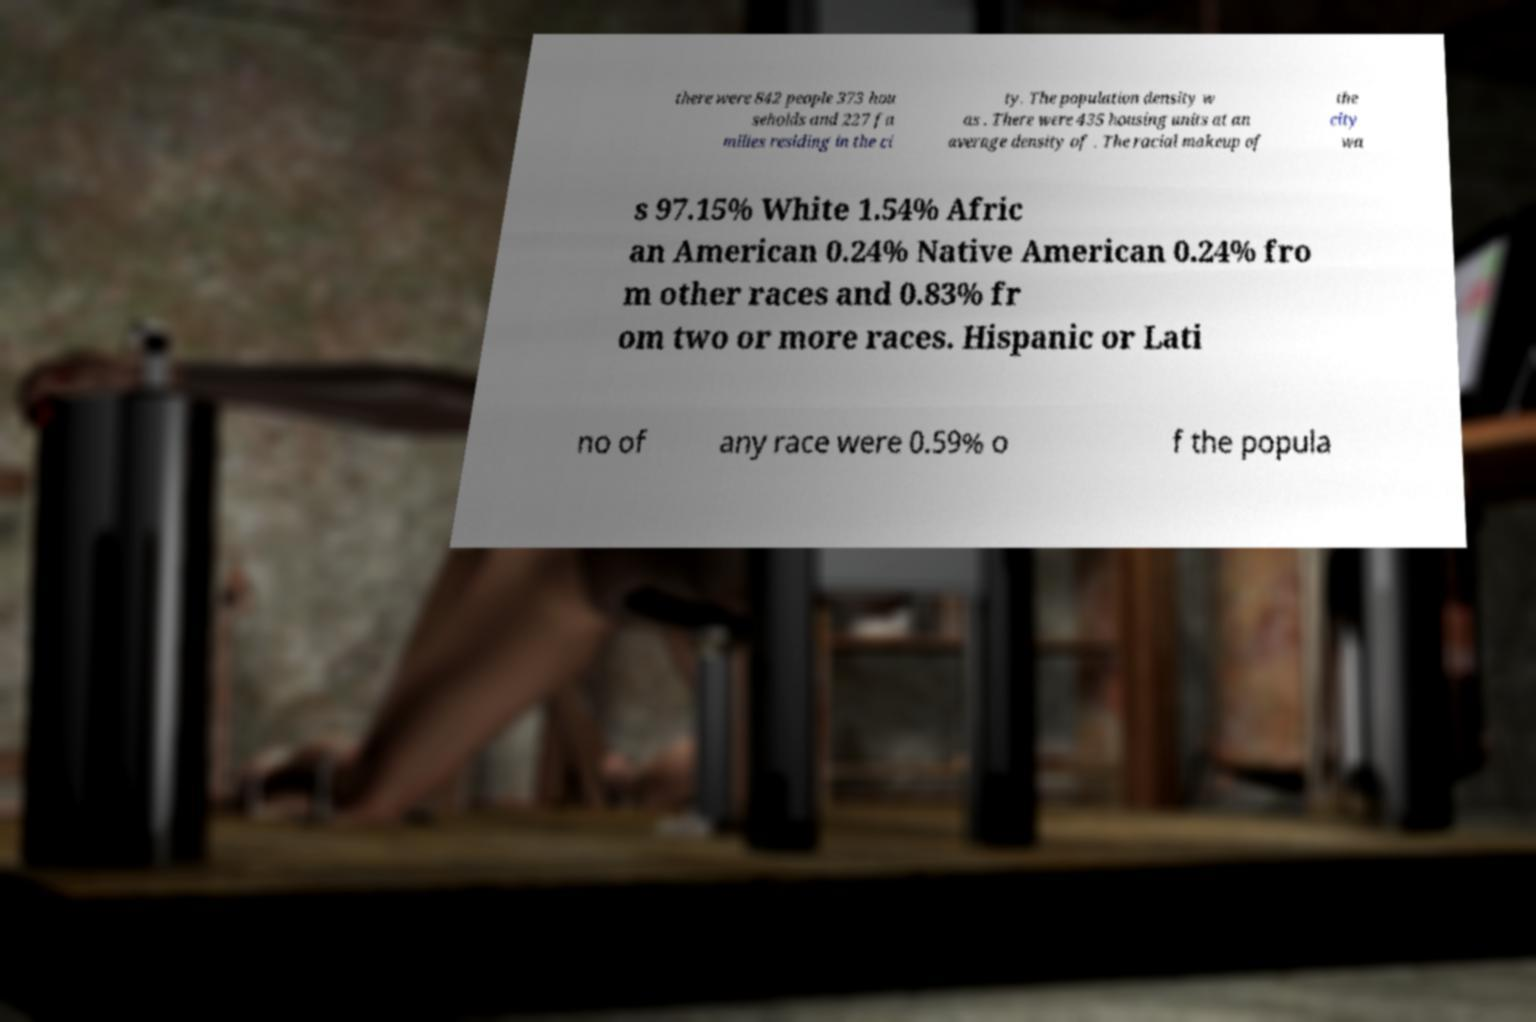For documentation purposes, I need the text within this image transcribed. Could you provide that? there were 842 people 373 hou seholds and 227 fa milies residing in the ci ty. The population density w as . There were 435 housing units at an average density of . The racial makeup of the city wa s 97.15% White 1.54% Afric an American 0.24% Native American 0.24% fro m other races and 0.83% fr om two or more races. Hispanic or Lati no of any race were 0.59% o f the popula 